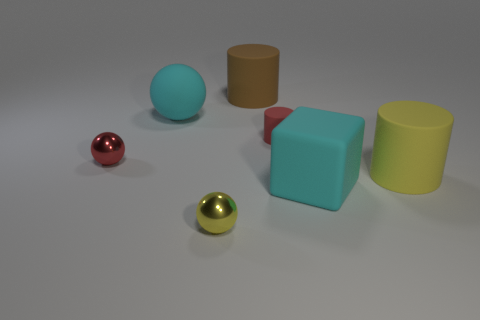How many objects are there in the image, and can you describe their shapes and colors? There are five objects in the image. Starting from the left, there's a small red sphere, a larger cyan sphere, a big cyan cube, a medium-sized golden cylinder, and a large yellow cylinder. Their colors range from vivid red and gold to more muted cyan and yellow. 